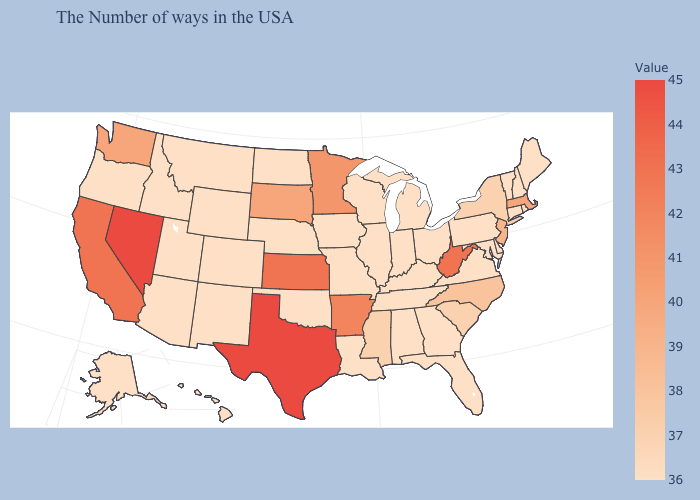Which states have the lowest value in the USA?
Be succinct. Maine, Rhode Island, New Hampshire, Vermont, Connecticut, Delaware, Maryland, Pennsylvania, Virginia, Ohio, Florida, Georgia, Michigan, Kentucky, Indiana, Alabama, Tennessee, Wisconsin, Illinois, Louisiana, Missouri, Iowa, Nebraska, Oklahoma, North Dakota, Wyoming, Colorado, New Mexico, Utah, Montana, Arizona, Idaho, Oregon, Alaska, Hawaii. Does the map have missing data?
Concise answer only. No. Is the legend a continuous bar?
Short answer required. Yes. Is the legend a continuous bar?
Quick response, please. Yes. 